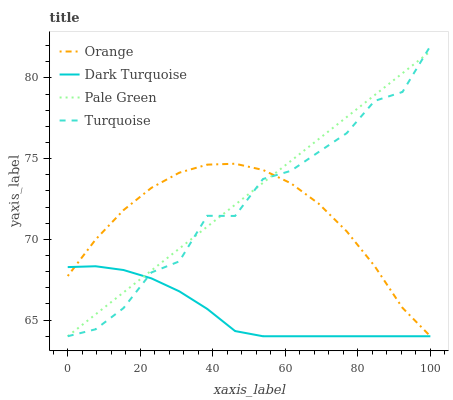Does Dark Turquoise have the minimum area under the curve?
Answer yes or no. Yes. Does Pale Green have the maximum area under the curve?
Answer yes or no. Yes. Does Turquoise have the minimum area under the curve?
Answer yes or no. No. Does Turquoise have the maximum area under the curve?
Answer yes or no. No. Is Pale Green the smoothest?
Answer yes or no. Yes. Is Turquoise the roughest?
Answer yes or no. Yes. Is Dark Turquoise the smoothest?
Answer yes or no. No. Is Dark Turquoise the roughest?
Answer yes or no. No. Does Orange have the lowest value?
Answer yes or no. Yes. Does Turquoise have the highest value?
Answer yes or no. Yes. Does Dark Turquoise have the highest value?
Answer yes or no. No. Does Dark Turquoise intersect Turquoise?
Answer yes or no. Yes. Is Dark Turquoise less than Turquoise?
Answer yes or no. No. Is Dark Turquoise greater than Turquoise?
Answer yes or no. No. 